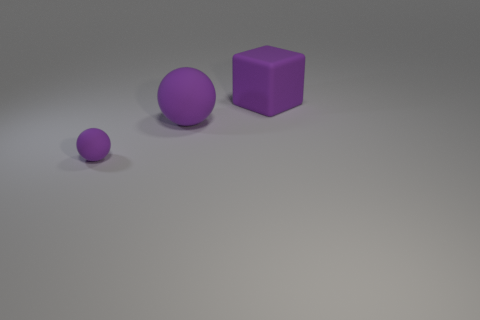Can you describe the sizes of the objects from smallest to largest? Sure, starting with the smallest, there's a tiny rubber ball, then the medium-sized rubber ball, and the largest object is the purple block. 